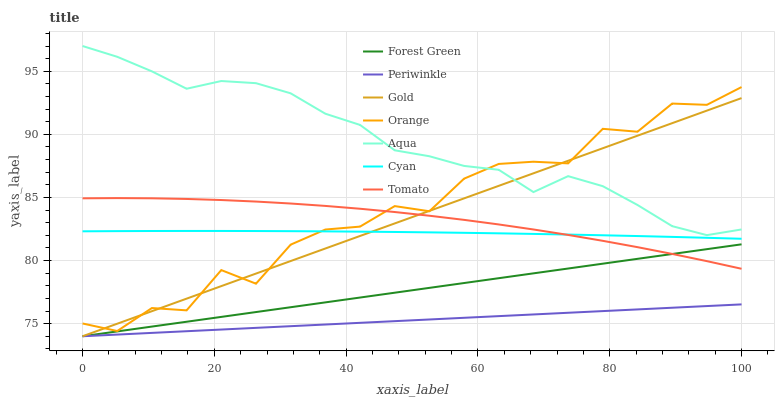Does Periwinkle have the minimum area under the curve?
Answer yes or no. Yes. Does Aqua have the maximum area under the curve?
Answer yes or no. Yes. Does Gold have the minimum area under the curve?
Answer yes or no. No. Does Gold have the maximum area under the curve?
Answer yes or no. No. Is Periwinkle the smoothest?
Answer yes or no. Yes. Is Orange the roughest?
Answer yes or no. Yes. Is Gold the smoothest?
Answer yes or no. No. Is Gold the roughest?
Answer yes or no. No. Does Gold have the lowest value?
Answer yes or no. Yes. Does Aqua have the lowest value?
Answer yes or no. No. Does Aqua have the highest value?
Answer yes or no. Yes. Does Gold have the highest value?
Answer yes or no. No. Is Cyan less than Aqua?
Answer yes or no. Yes. Is Aqua greater than Forest Green?
Answer yes or no. Yes. Does Orange intersect Aqua?
Answer yes or no. Yes. Is Orange less than Aqua?
Answer yes or no. No. Is Orange greater than Aqua?
Answer yes or no. No. Does Cyan intersect Aqua?
Answer yes or no. No. 